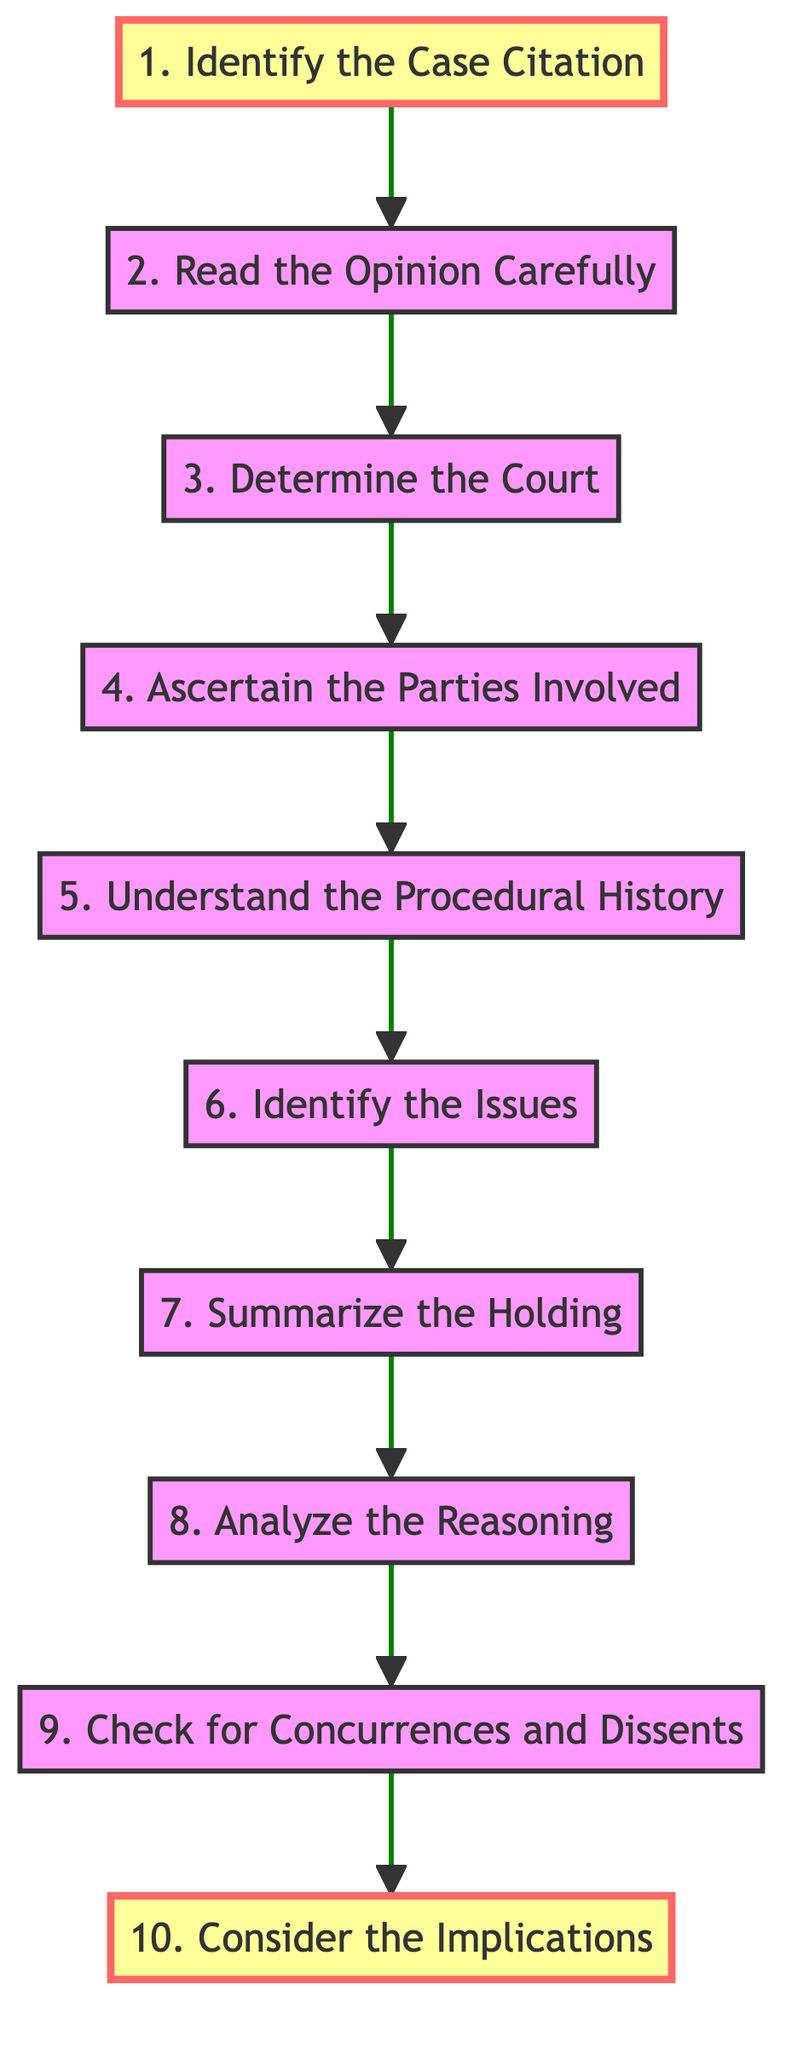What is the first step in the flowchart? The flowchart indicates that the first step is "Identify the Case Citation," which directly connects to the second step.
Answer: Identify the Case Citation How many steps are there in total in the flowchart? By counting the numbered steps from 1 to 10 in the flowchart, we find that there are ten steps in total.
Answer: 10 Which step directly follows "Understand the Procedural History"? The diagram shows that "Identify the Issues" is the step that directly follows "Understand the Procedural History."
Answer: Identify the Issues What is the last step listed in the flowchart? The flowchart displays "Consider the Implications" as the last step, as it is the final node at the end of the sequence.
Answer: Consider the Implications Which steps are marked as important in the flowchart? The flowchart highlights "Identify the Case Citation" and "Consider the Implications" as the important steps through color coding.
Answer: Identify the Case Citation, Consider the Implications What is the relationship between "Summarize the Holding" and "Analyze the Reasoning"? According to the flowchart, "Summarize the Holding" precedes "Analyze the Reasoning," indicating a sequential flow where one step leads to the next.
Answer: Summarize the Holding precedes Analyze the Reasoning How many steps come after "Identify the Issues"? The flowchart shows that there are three steps that come after "Identify the Issues," specifically: "Summarize the Holding," "Analyze the Reasoning," and "Check for Concurrences and Dissents."
Answer: 3 Which step identifies the parties involved in the case? The flowchart specifies that "Ascertain the Parties Involved" is the step dedicated to this purpose, making it clear which parties are part of the case.
Answer: Ascertain the Parties Involved What is the primary focus of the step titled "Analyze the Reasoning"? The flowchart mentions that "Analyze the Reasoning" focuses on examining the court's rationale, including principles and precedents.
Answer: Examining the court's rationale What kind of opinions should be checked for at the final step? At the final step, the flowchart requests checking for "Concurrences and Dissents," which refers to separate opinions that either agree or disagree with the majority opinion.
Answer: Concurrences and Dissents 